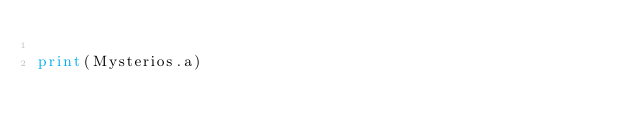Convert code to text. <code><loc_0><loc_0><loc_500><loc_500><_Python_>
print(Mysterios.a)</code> 